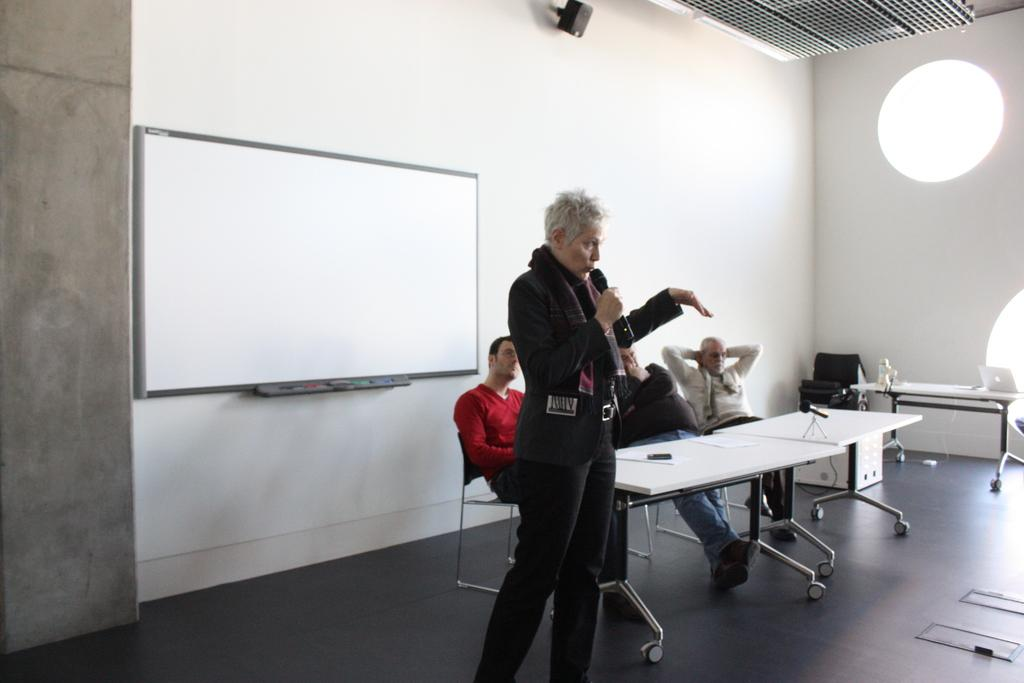Who is the main subject in the image? There is image? What is the woman holding in her hand? The woman is holding a mic in her hand. How many men are in the image? There are three men in the image. What are the men doing in the image? The men are sitting at a table. What type of stamp can be seen on the woman's skirt in the image? There is no stamp or skirt present in the image; the woman is holding a mic and there are no references to clothing. 